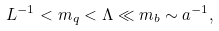<formula> <loc_0><loc_0><loc_500><loc_500>L ^ { - 1 } < m _ { q } < \Lambda \ll m _ { b } \sim a ^ { - 1 } ,</formula> 